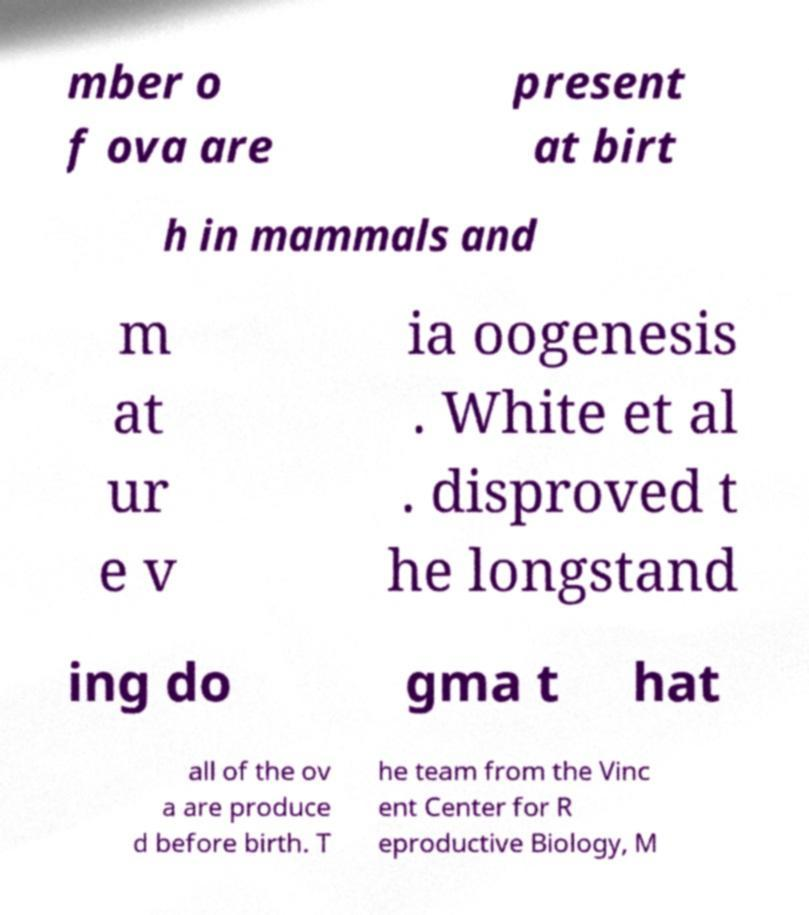For documentation purposes, I need the text within this image transcribed. Could you provide that? mber o f ova are present at birt h in mammals and m at ur e v ia oogenesis . White et al . disproved t he longstand ing do gma t hat all of the ov a are produce d before birth. T he team from the Vinc ent Center for R eproductive Biology, M 